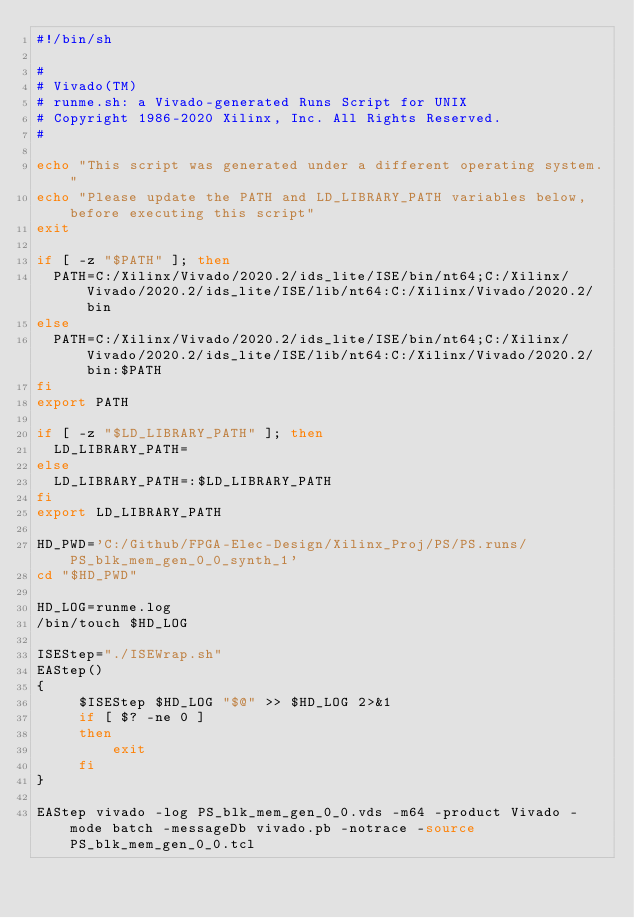Convert code to text. <code><loc_0><loc_0><loc_500><loc_500><_Bash_>#!/bin/sh

# 
# Vivado(TM)
# runme.sh: a Vivado-generated Runs Script for UNIX
# Copyright 1986-2020 Xilinx, Inc. All Rights Reserved.
# 

echo "This script was generated under a different operating system."
echo "Please update the PATH and LD_LIBRARY_PATH variables below, before executing this script"
exit

if [ -z "$PATH" ]; then
  PATH=C:/Xilinx/Vivado/2020.2/ids_lite/ISE/bin/nt64;C:/Xilinx/Vivado/2020.2/ids_lite/ISE/lib/nt64:C:/Xilinx/Vivado/2020.2/bin
else
  PATH=C:/Xilinx/Vivado/2020.2/ids_lite/ISE/bin/nt64;C:/Xilinx/Vivado/2020.2/ids_lite/ISE/lib/nt64:C:/Xilinx/Vivado/2020.2/bin:$PATH
fi
export PATH

if [ -z "$LD_LIBRARY_PATH" ]; then
  LD_LIBRARY_PATH=
else
  LD_LIBRARY_PATH=:$LD_LIBRARY_PATH
fi
export LD_LIBRARY_PATH

HD_PWD='C:/Github/FPGA-Elec-Design/Xilinx_Proj/PS/PS.runs/PS_blk_mem_gen_0_0_synth_1'
cd "$HD_PWD"

HD_LOG=runme.log
/bin/touch $HD_LOG

ISEStep="./ISEWrap.sh"
EAStep()
{
     $ISEStep $HD_LOG "$@" >> $HD_LOG 2>&1
     if [ $? -ne 0 ]
     then
         exit
     fi
}

EAStep vivado -log PS_blk_mem_gen_0_0.vds -m64 -product Vivado -mode batch -messageDb vivado.pb -notrace -source PS_blk_mem_gen_0_0.tcl
</code> 